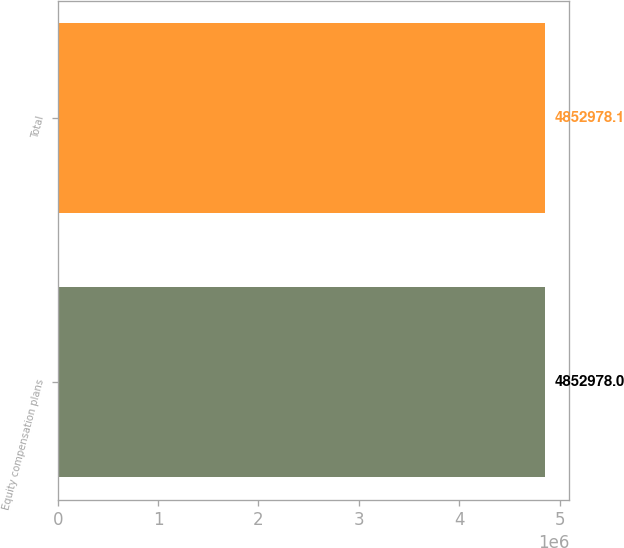Convert chart. <chart><loc_0><loc_0><loc_500><loc_500><bar_chart><fcel>Equity compensation plans<fcel>Total<nl><fcel>4.85298e+06<fcel>4.85298e+06<nl></chart> 